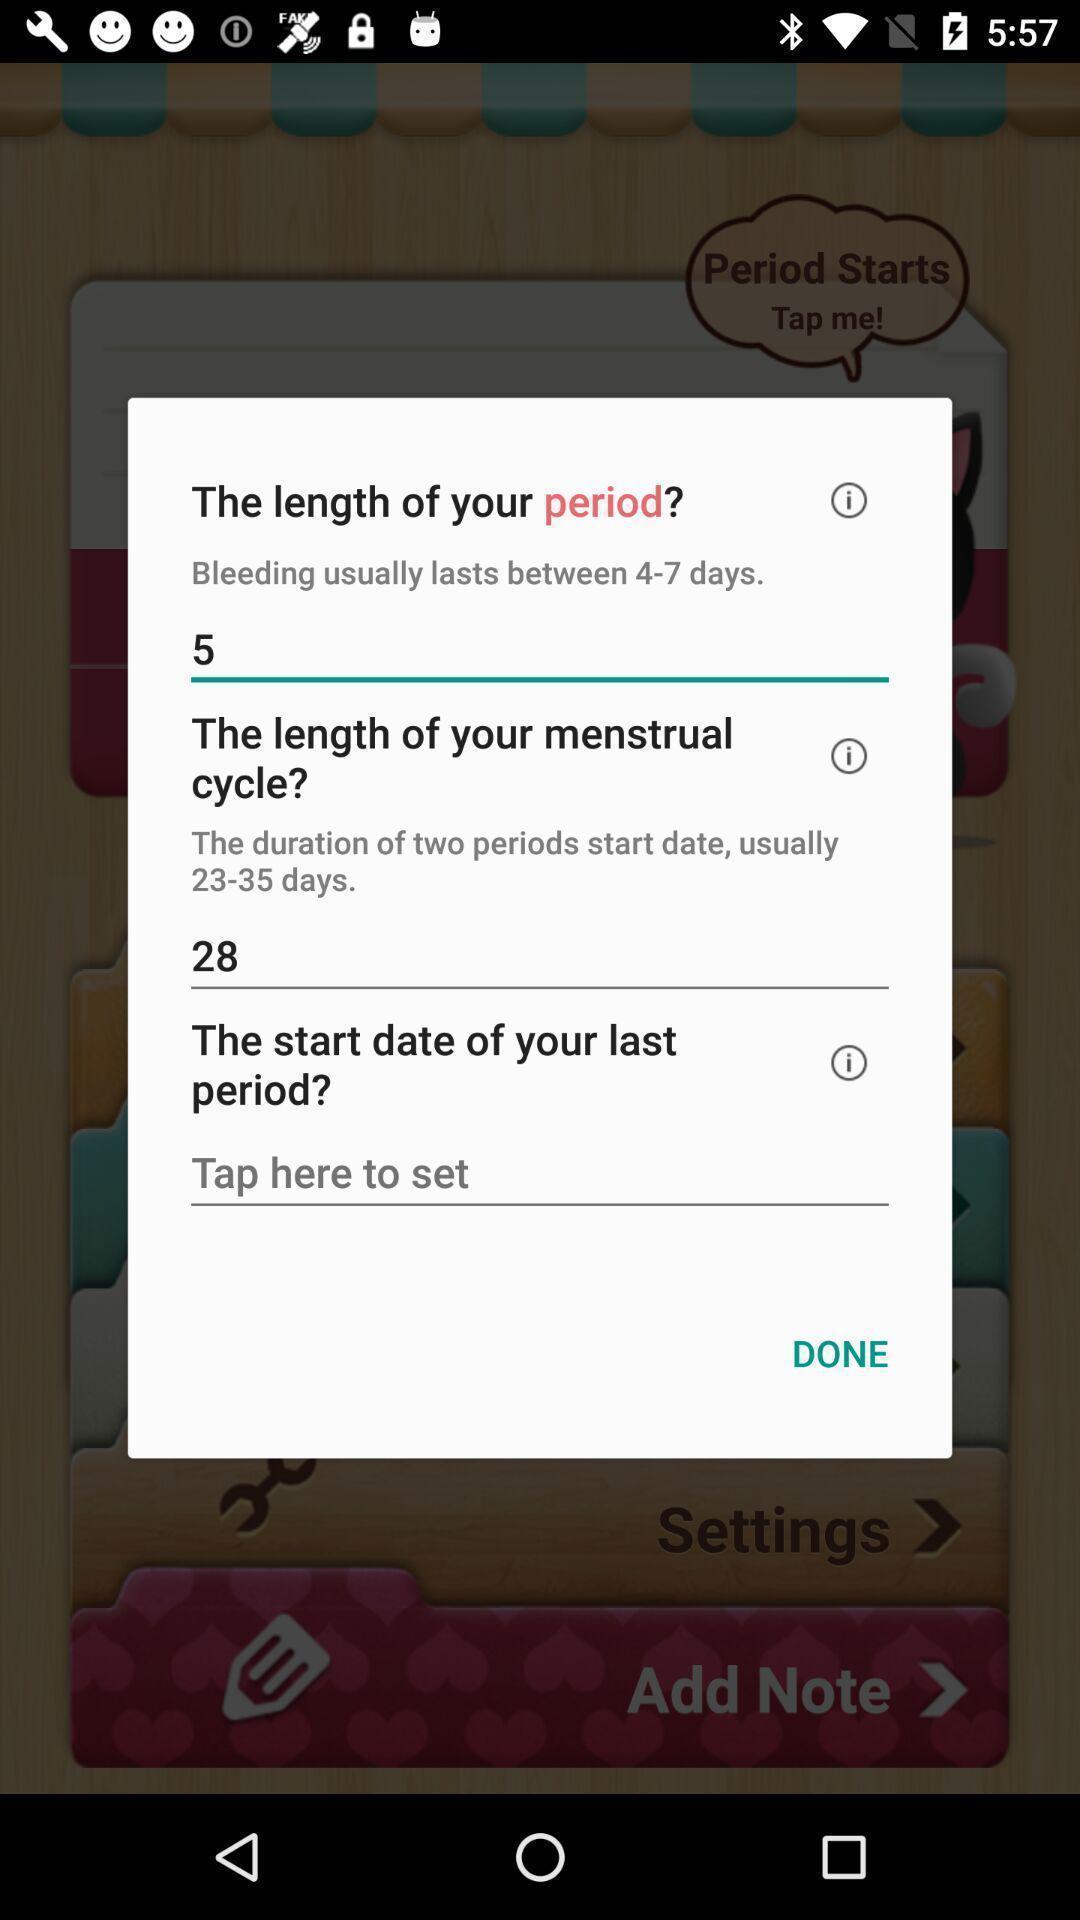What is the overall content of this screenshot? Pop-up showing the three fields to fill the details. 